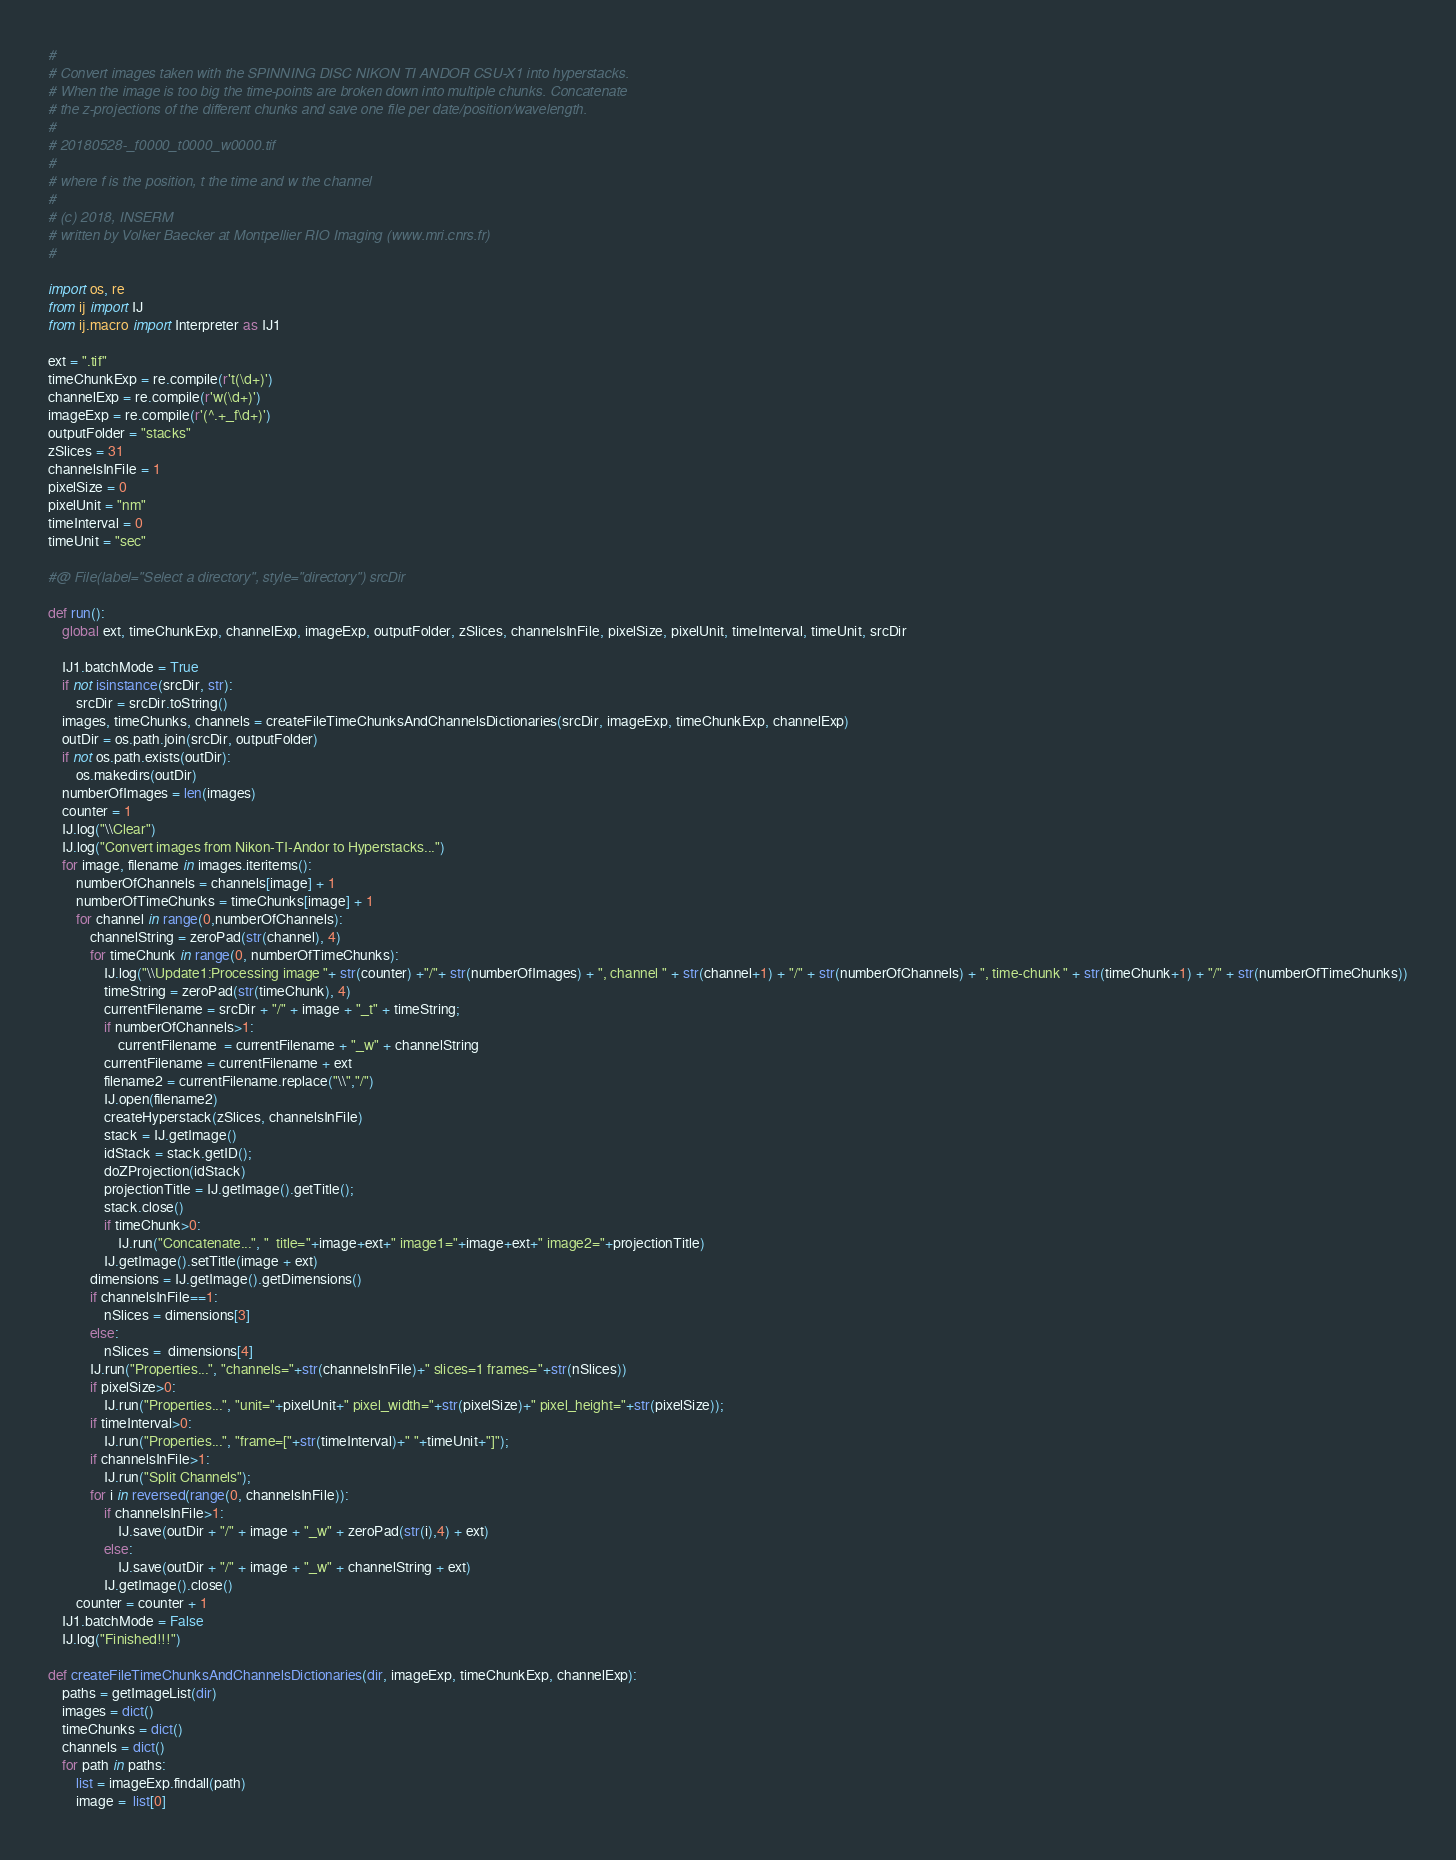<code> <loc_0><loc_0><loc_500><loc_500><_Python_>#
# Convert images taken with the SPINNING DISC NIKON TI ANDOR CSU-X1 into hyperstacks. 
# When the image is too big the time-points are broken down into multiple chunks. Concatenate
# the z-projections of the different chunks and save one file per date/position/wavelength.
#
# 20180528-_f0000_t0000_w0000.tif
#
# where f is the position, t the time and w the channel
# 
# (c) 2018, INSERM
# written by Volker Baecker at Montpellier RIO Imaging (www.mri.cnrs.fr)
# 
 
import os, re
from ij import IJ
from ij.macro import Interpreter as IJ1

ext = ".tif"
timeChunkExp = re.compile(r't(\d+)')
channelExp = re.compile(r'w(\d+)')
imageExp = re.compile(r'(^.+_f\d+)')
outputFolder = "stacks"
zSlices = 31
channelsInFile = 1
pixelSize = 0
pixelUnit = "nm"
timeInterval = 0
timeUnit = "sec"

#@ File(label="Select a directory", style="directory") srcDir

def run():
	global ext, timeChunkExp, channelExp, imageExp, outputFolder, zSlices, channelsInFile, pixelSize, pixelUnit, timeInterval, timeUnit, srcDir
	
	IJ1.batchMode = True
	if not isinstance(srcDir, str): 
		srcDir = srcDir.toString()
	images, timeChunks, channels = createFileTimeChunksAndChannelsDictionaries(srcDir, imageExp, timeChunkExp, channelExp)
	outDir = os.path.join(srcDir, outputFolder)
	if not os.path.exists(outDir):
		os.makedirs(outDir)
	numberOfImages = len(images)
	counter = 1
	IJ.log("\\Clear")
	IJ.log("Convert images from Nikon-TI-Andor to Hyperstacks...")
	for image, filename in images.iteritems():
		numberOfChannels = channels[image] + 1
		numberOfTimeChunks = timeChunks[image] + 1
		for channel in range(0,numberOfChannels):
			channelString = zeroPad(str(channel), 4)
			for timeChunk in range(0, numberOfTimeChunks):
				IJ.log("\\Update1:Processing image "+ str(counter) +"/"+ str(numberOfImages) + ", channel " + str(channel+1) + "/" + str(numberOfChannels) + ", time-chunk " + str(timeChunk+1) + "/" + str(numberOfTimeChunks))
				timeString = zeroPad(str(timeChunk), 4)
				currentFilename = srcDir + "/" + image + "_t" + timeString;
				if numberOfChannels>1:
					currentFilename  = currentFilename + "_w" + channelString 
				currentFilename = currentFilename + ext
				filename2 = currentFilename.replace("\\","/") 
				IJ.open(filename2)
				createHyperstack(zSlices, channelsInFile)	
				stack = IJ.getImage()
				idStack = stack.getID();
				doZProjection(idStack)
				projectionTitle = IJ.getImage().getTitle();
				stack.close()
				if timeChunk>0:
					IJ.run("Concatenate...", "  title="+image+ext+" image1="+image+ext+" image2="+projectionTitle)
				IJ.getImage().setTitle(image + ext)
			dimensions = IJ.getImage().getDimensions()
			if channelsInFile==1:
				nSlices = dimensions[3]
			else: 
				nSlices =  dimensions[4]
			IJ.run("Properties...", "channels="+str(channelsInFile)+" slices=1 frames="+str(nSlices))
			if pixelSize>0:
				IJ.run("Properties...", "unit="+pixelUnit+" pixel_width="+str(pixelSize)+" pixel_height="+str(pixelSize));
			if timeInterval>0:
				IJ.run("Properties...", "frame=["+str(timeInterval)+" "+timeUnit+"]");
			if channelsInFile>1:
				IJ.run("Split Channels");
			for i in reversed(range(0, channelsInFile)):	
				if channelsInFile>1:
					IJ.save(outDir + "/" + image + "_w" + zeroPad(str(i),4) + ext)
				else:
					IJ.save(outDir + "/" + image + "_w" + channelString + ext)
				IJ.getImage().close()
		counter = counter + 1
	IJ1.batchMode = False
	IJ.log("Finished!!!")
	
def createFileTimeChunksAndChannelsDictionaries(dir, imageExp, timeChunkExp, channelExp):
	paths = getImageList(dir)
	images = dict()
	timeChunks = dict()
	channels = dict()
	for path in paths:
		list = imageExp.findall(path)
		image =  list[0]</code> 